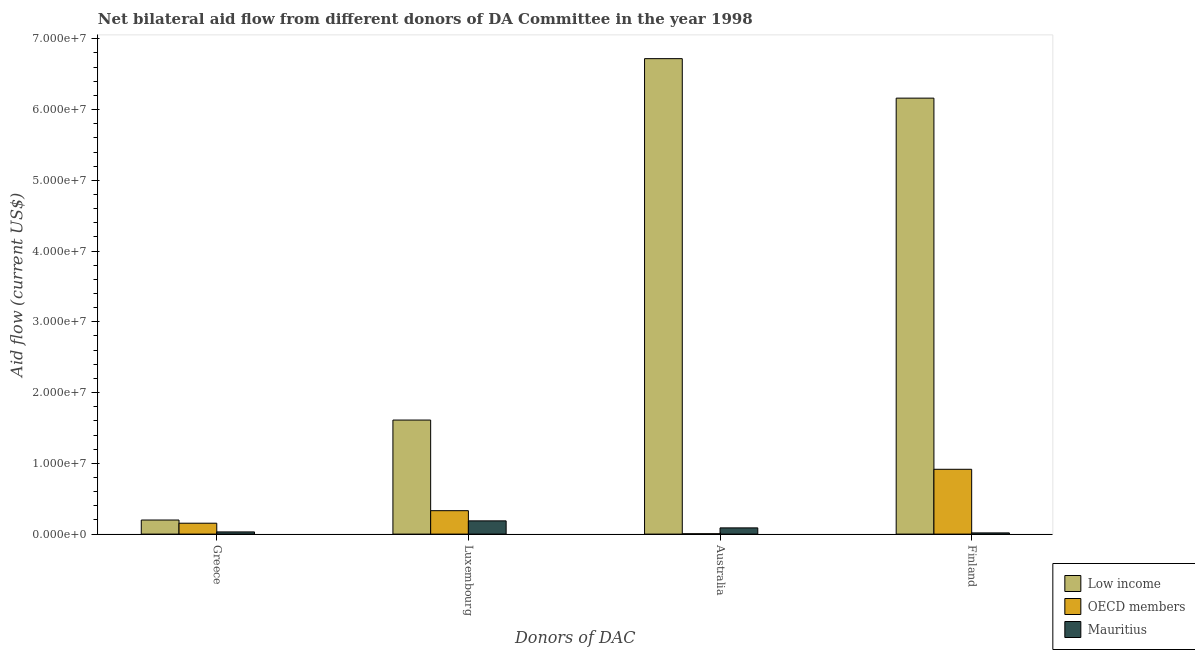How many different coloured bars are there?
Your answer should be very brief. 3. Are the number of bars per tick equal to the number of legend labels?
Offer a terse response. Yes. Are the number of bars on each tick of the X-axis equal?
Keep it short and to the point. Yes. How many bars are there on the 2nd tick from the left?
Offer a very short reply. 3. What is the amount of aid given by greece in OECD members?
Your answer should be very brief. 1.54e+06. Across all countries, what is the maximum amount of aid given by australia?
Provide a short and direct response. 6.72e+07. Across all countries, what is the minimum amount of aid given by australia?
Your answer should be very brief. 5.00e+04. In which country was the amount of aid given by luxembourg minimum?
Provide a short and direct response. Mauritius. What is the total amount of aid given by greece in the graph?
Provide a succinct answer. 3.84e+06. What is the difference between the amount of aid given by finland in Mauritius and that in Low income?
Your answer should be very brief. -6.14e+07. What is the difference between the amount of aid given by australia in OECD members and the amount of aid given by greece in Mauritius?
Give a very brief answer. -2.60e+05. What is the average amount of aid given by finland per country?
Offer a very short reply. 2.36e+07. What is the difference between the amount of aid given by luxembourg and amount of aid given by finland in OECD members?
Your answer should be compact. -5.85e+06. What is the ratio of the amount of aid given by greece in Mauritius to that in Low income?
Your answer should be very brief. 0.16. What is the difference between the highest and the lowest amount of aid given by greece?
Provide a short and direct response. 1.68e+06. In how many countries, is the amount of aid given by greece greater than the average amount of aid given by greece taken over all countries?
Offer a terse response. 2. Is the sum of the amount of aid given by luxembourg in Low income and OECD members greater than the maximum amount of aid given by greece across all countries?
Ensure brevity in your answer.  Yes. Is it the case that in every country, the sum of the amount of aid given by luxembourg and amount of aid given by australia is greater than the sum of amount of aid given by greece and amount of aid given by finland?
Your response must be concise. No. What does the 2nd bar from the left in Greece represents?
Make the answer very short. OECD members. Are all the bars in the graph horizontal?
Make the answer very short. No. What is the difference between two consecutive major ticks on the Y-axis?
Make the answer very short. 1.00e+07. Does the graph contain any zero values?
Provide a short and direct response. No. What is the title of the graph?
Provide a short and direct response. Net bilateral aid flow from different donors of DA Committee in the year 1998. Does "France" appear as one of the legend labels in the graph?
Provide a short and direct response. No. What is the label or title of the X-axis?
Give a very brief answer. Donors of DAC. What is the label or title of the Y-axis?
Offer a very short reply. Aid flow (current US$). What is the Aid flow (current US$) of Low income in Greece?
Ensure brevity in your answer.  1.99e+06. What is the Aid flow (current US$) of OECD members in Greece?
Ensure brevity in your answer.  1.54e+06. What is the Aid flow (current US$) in Low income in Luxembourg?
Keep it short and to the point. 1.61e+07. What is the Aid flow (current US$) in OECD members in Luxembourg?
Your answer should be compact. 3.31e+06. What is the Aid flow (current US$) of Mauritius in Luxembourg?
Provide a succinct answer. 1.87e+06. What is the Aid flow (current US$) in Low income in Australia?
Provide a succinct answer. 6.72e+07. What is the Aid flow (current US$) in OECD members in Australia?
Give a very brief answer. 5.00e+04. What is the Aid flow (current US$) in Mauritius in Australia?
Provide a short and direct response. 8.80e+05. What is the Aid flow (current US$) of Low income in Finland?
Provide a short and direct response. 6.16e+07. What is the Aid flow (current US$) of OECD members in Finland?
Make the answer very short. 9.16e+06. Across all Donors of DAC, what is the maximum Aid flow (current US$) of Low income?
Make the answer very short. 6.72e+07. Across all Donors of DAC, what is the maximum Aid flow (current US$) of OECD members?
Make the answer very short. 9.16e+06. Across all Donors of DAC, what is the maximum Aid flow (current US$) of Mauritius?
Your response must be concise. 1.87e+06. Across all Donors of DAC, what is the minimum Aid flow (current US$) in Low income?
Provide a succinct answer. 1.99e+06. Across all Donors of DAC, what is the minimum Aid flow (current US$) in OECD members?
Your answer should be very brief. 5.00e+04. Across all Donors of DAC, what is the minimum Aid flow (current US$) in Mauritius?
Ensure brevity in your answer.  1.70e+05. What is the total Aid flow (current US$) of Low income in the graph?
Offer a terse response. 1.47e+08. What is the total Aid flow (current US$) in OECD members in the graph?
Your response must be concise. 1.41e+07. What is the total Aid flow (current US$) in Mauritius in the graph?
Your answer should be very brief. 3.23e+06. What is the difference between the Aid flow (current US$) of Low income in Greece and that in Luxembourg?
Give a very brief answer. -1.41e+07. What is the difference between the Aid flow (current US$) of OECD members in Greece and that in Luxembourg?
Make the answer very short. -1.77e+06. What is the difference between the Aid flow (current US$) of Mauritius in Greece and that in Luxembourg?
Make the answer very short. -1.56e+06. What is the difference between the Aid flow (current US$) of Low income in Greece and that in Australia?
Provide a short and direct response. -6.52e+07. What is the difference between the Aid flow (current US$) in OECD members in Greece and that in Australia?
Your answer should be compact. 1.49e+06. What is the difference between the Aid flow (current US$) of Mauritius in Greece and that in Australia?
Provide a succinct answer. -5.70e+05. What is the difference between the Aid flow (current US$) in Low income in Greece and that in Finland?
Offer a very short reply. -5.96e+07. What is the difference between the Aid flow (current US$) in OECD members in Greece and that in Finland?
Make the answer very short. -7.62e+06. What is the difference between the Aid flow (current US$) of Mauritius in Greece and that in Finland?
Make the answer very short. 1.40e+05. What is the difference between the Aid flow (current US$) in Low income in Luxembourg and that in Australia?
Make the answer very short. -5.11e+07. What is the difference between the Aid flow (current US$) in OECD members in Luxembourg and that in Australia?
Offer a terse response. 3.26e+06. What is the difference between the Aid flow (current US$) in Mauritius in Luxembourg and that in Australia?
Give a very brief answer. 9.90e+05. What is the difference between the Aid flow (current US$) in Low income in Luxembourg and that in Finland?
Offer a terse response. -4.55e+07. What is the difference between the Aid flow (current US$) in OECD members in Luxembourg and that in Finland?
Provide a succinct answer. -5.85e+06. What is the difference between the Aid flow (current US$) of Mauritius in Luxembourg and that in Finland?
Make the answer very short. 1.70e+06. What is the difference between the Aid flow (current US$) in Low income in Australia and that in Finland?
Offer a terse response. 5.58e+06. What is the difference between the Aid flow (current US$) of OECD members in Australia and that in Finland?
Give a very brief answer. -9.11e+06. What is the difference between the Aid flow (current US$) of Mauritius in Australia and that in Finland?
Your answer should be very brief. 7.10e+05. What is the difference between the Aid flow (current US$) in Low income in Greece and the Aid flow (current US$) in OECD members in Luxembourg?
Provide a succinct answer. -1.32e+06. What is the difference between the Aid flow (current US$) of Low income in Greece and the Aid flow (current US$) of Mauritius in Luxembourg?
Offer a terse response. 1.20e+05. What is the difference between the Aid flow (current US$) in OECD members in Greece and the Aid flow (current US$) in Mauritius in Luxembourg?
Your response must be concise. -3.30e+05. What is the difference between the Aid flow (current US$) in Low income in Greece and the Aid flow (current US$) in OECD members in Australia?
Your answer should be very brief. 1.94e+06. What is the difference between the Aid flow (current US$) of Low income in Greece and the Aid flow (current US$) of Mauritius in Australia?
Ensure brevity in your answer.  1.11e+06. What is the difference between the Aid flow (current US$) in Low income in Greece and the Aid flow (current US$) in OECD members in Finland?
Provide a short and direct response. -7.17e+06. What is the difference between the Aid flow (current US$) in Low income in Greece and the Aid flow (current US$) in Mauritius in Finland?
Your response must be concise. 1.82e+06. What is the difference between the Aid flow (current US$) in OECD members in Greece and the Aid flow (current US$) in Mauritius in Finland?
Ensure brevity in your answer.  1.37e+06. What is the difference between the Aid flow (current US$) in Low income in Luxembourg and the Aid flow (current US$) in OECD members in Australia?
Your answer should be compact. 1.61e+07. What is the difference between the Aid flow (current US$) in Low income in Luxembourg and the Aid flow (current US$) in Mauritius in Australia?
Your answer should be very brief. 1.52e+07. What is the difference between the Aid flow (current US$) of OECD members in Luxembourg and the Aid flow (current US$) of Mauritius in Australia?
Your response must be concise. 2.43e+06. What is the difference between the Aid flow (current US$) of Low income in Luxembourg and the Aid flow (current US$) of OECD members in Finland?
Your response must be concise. 6.96e+06. What is the difference between the Aid flow (current US$) in Low income in Luxembourg and the Aid flow (current US$) in Mauritius in Finland?
Keep it short and to the point. 1.60e+07. What is the difference between the Aid flow (current US$) of OECD members in Luxembourg and the Aid flow (current US$) of Mauritius in Finland?
Offer a terse response. 3.14e+06. What is the difference between the Aid flow (current US$) in Low income in Australia and the Aid flow (current US$) in OECD members in Finland?
Ensure brevity in your answer.  5.80e+07. What is the difference between the Aid flow (current US$) of Low income in Australia and the Aid flow (current US$) of Mauritius in Finland?
Give a very brief answer. 6.70e+07. What is the difference between the Aid flow (current US$) of OECD members in Australia and the Aid flow (current US$) of Mauritius in Finland?
Make the answer very short. -1.20e+05. What is the average Aid flow (current US$) in Low income per Donors of DAC?
Make the answer very short. 3.67e+07. What is the average Aid flow (current US$) of OECD members per Donors of DAC?
Ensure brevity in your answer.  3.52e+06. What is the average Aid flow (current US$) of Mauritius per Donors of DAC?
Provide a succinct answer. 8.08e+05. What is the difference between the Aid flow (current US$) in Low income and Aid flow (current US$) in OECD members in Greece?
Keep it short and to the point. 4.50e+05. What is the difference between the Aid flow (current US$) in Low income and Aid flow (current US$) in Mauritius in Greece?
Make the answer very short. 1.68e+06. What is the difference between the Aid flow (current US$) in OECD members and Aid flow (current US$) in Mauritius in Greece?
Your answer should be compact. 1.23e+06. What is the difference between the Aid flow (current US$) of Low income and Aid flow (current US$) of OECD members in Luxembourg?
Offer a terse response. 1.28e+07. What is the difference between the Aid flow (current US$) of Low income and Aid flow (current US$) of Mauritius in Luxembourg?
Provide a succinct answer. 1.42e+07. What is the difference between the Aid flow (current US$) of OECD members and Aid flow (current US$) of Mauritius in Luxembourg?
Your answer should be compact. 1.44e+06. What is the difference between the Aid flow (current US$) in Low income and Aid flow (current US$) in OECD members in Australia?
Provide a short and direct response. 6.72e+07. What is the difference between the Aid flow (current US$) of Low income and Aid flow (current US$) of Mauritius in Australia?
Make the answer very short. 6.63e+07. What is the difference between the Aid flow (current US$) of OECD members and Aid flow (current US$) of Mauritius in Australia?
Your answer should be compact. -8.30e+05. What is the difference between the Aid flow (current US$) in Low income and Aid flow (current US$) in OECD members in Finland?
Give a very brief answer. 5.25e+07. What is the difference between the Aid flow (current US$) of Low income and Aid flow (current US$) of Mauritius in Finland?
Offer a very short reply. 6.14e+07. What is the difference between the Aid flow (current US$) in OECD members and Aid flow (current US$) in Mauritius in Finland?
Ensure brevity in your answer.  8.99e+06. What is the ratio of the Aid flow (current US$) in Low income in Greece to that in Luxembourg?
Offer a very short reply. 0.12. What is the ratio of the Aid flow (current US$) of OECD members in Greece to that in Luxembourg?
Offer a very short reply. 0.47. What is the ratio of the Aid flow (current US$) of Mauritius in Greece to that in Luxembourg?
Your response must be concise. 0.17. What is the ratio of the Aid flow (current US$) in Low income in Greece to that in Australia?
Offer a terse response. 0.03. What is the ratio of the Aid flow (current US$) in OECD members in Greece to that in Australia?
Your response must be concise. 30.8. What is the ratio of the Aid flow (current US$) of Mauritius in Greece to that in Australia?
Your answer should be very brief. 0.35. What is the ratio of the Aid flow (current US$) in Low income in Greece to that in Finland?
Provide a succinct answer. 0.03. What is the ratio of the Aid flow (current US$) of OECD members in Greece to that in Finland?
Give a very brief answer. 0.17. What is the ratio of the Aid flow (current US$) of Mauritius in Greece to that in Finland?
Your answer should be very brief. 1.82. What is the ratio of the Aid flow (current US$) of Low income in Luxembourg to that in Australia?
Make the answer very short. 0.24. What is the ratio of the Aid flow (current US$) in OECD members in Luxembourg to that in Australia?
Ensure brevity in your answer.  66.2. What is the ratio of the Aid flow (current US$) in Mauritius in Luxembourg to that in Australia?
Ensure brevity in your answer.  2.12. What is the ratio of the Aid flow (current US$) in Low income in Luxembourg to that in Finland?
Offer a very short reply. 0.26. What is the ratio of the Aid flow (current US$) of OECD members in Luxembourg to that in Finland?
Provide a short and direct response. 0.36. What is the ratio of the Aid flow (current US$) in Mauritius in Luxembourg to that in Finland?
Your response must be concise. 11. What is the ratio of the Aid flow (current US$) in Low income in Australia to that in Finland?
Keep it short and to the point. 1.09. What is the ratio of the Aid flow (current US$) of OECD members in Australia to that in Finland?
Offer a very short reply. 0.01. What is the ratio of the Aid flow (current US$) of Mauritius in Australia to that in Finland?
Offer a terse response. 5.18. What is the difference between the highest and the second highest Aid flow (current US$) in Low income?
Provide a short and direct response. 5.58e+06. What is the difference between the highest and the second highest Aid flow (current US$) in OECD members?
Your answer should be very brief. 5.85e+06. What is the difference between the highest and the second highest Aid flow (current US$) in Mauritius?
Make the answer very short. 9.90e+05. What is the difference between the highest and the lowest Aid flow (current US$) in Low income?
Keep it short and to the point. 6.52e+07. What is the difference between the highest and the lowest Aid flow (current US$) in OECD members?
Your response must be concise. 9.11e+06. What is the difference between the highest and the lowest Aid flow (current US$) in Mauritius?
Keep it short and to the point. 1.70e+06. 